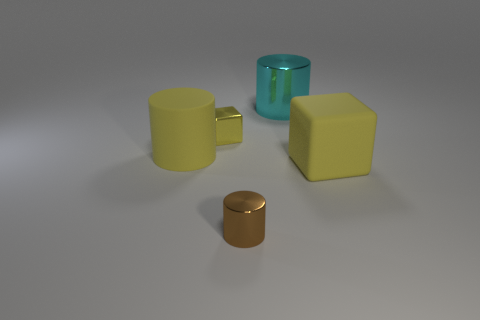Is the number of large cyan cylinders less than the number of small purple metallic blocks?
Provide a short and direct response. No. What number of small objects are either yellow matte objects or cylinders?
Offer a very short reply. 1. What number of objects are in front of the big cube and left of the tiny brown cylinder?
Offer a very short reply. 0. Are there more yellow matte objects than big matte blocks?
Offer a terse response. Yes. What number of other things are there of the same shape as the yellow metal thing?
Your answer should be compact. 1. Is the big matte cylinder the same color as the tiny shiny block?
Offer a terse response. Yes. There is a thing that is in front of the metallic cube and left of the brown metal cylinder; what is it made of?
Provide a short and direct response. Rubber. The brown cylinder is what size?
Provide a short and direct response. Small. What number of small blocks are on the right side of the rubber object right of the big rubber object that is on the left side of the big cyan object?
Your answer should be very brief. 0. There is a large rubber object on the left side of the yellow rubber object that is on the right side of the large cyan metal thing; what is its shape?
Offer a terse response. Cylinder. 